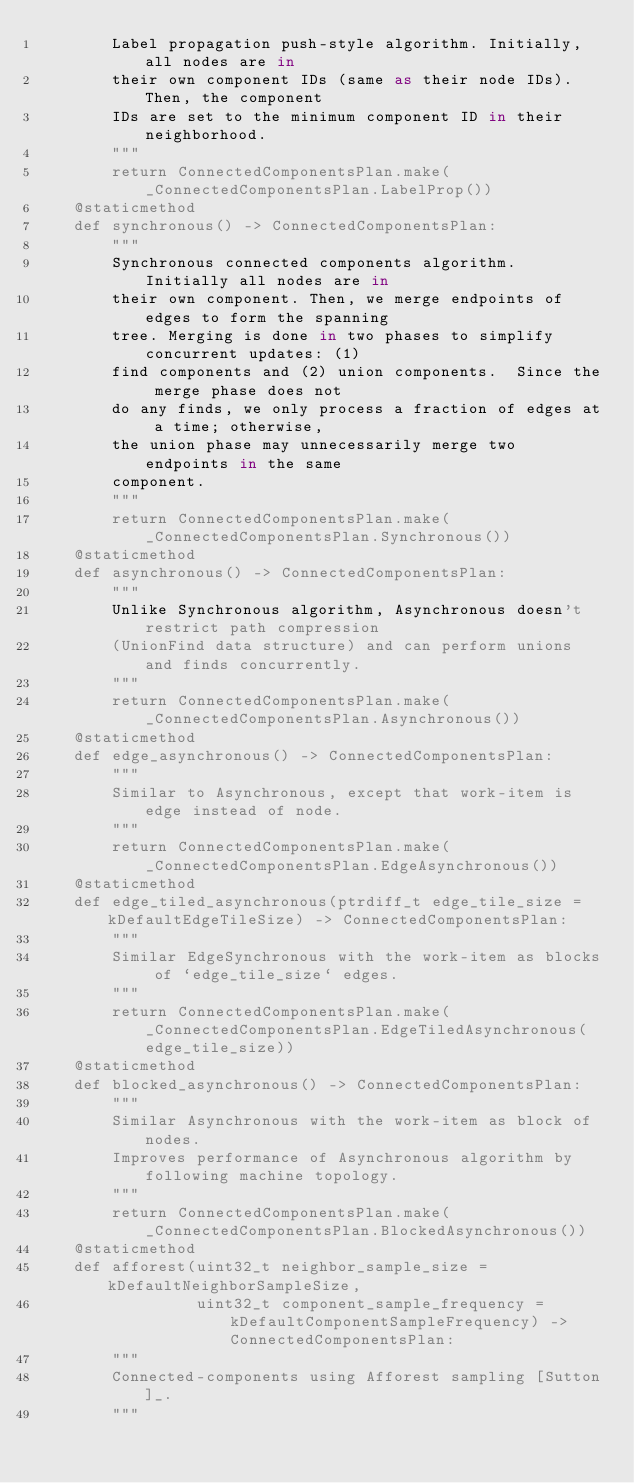<code> <loc_0><loc_0><loc_500><loc_500><_Cython_>        Label propagation push-style algorithm. Initially, all nodes are in
        their own component IDs (same as their node IDs). Then, the component
        IDs are set to the minimum component ID in their neighborhood.
        """
        return ConnectedComponentsPlan.make(_ConnectedComponentsPlan.LabelProp())
    @staticmethod
    def synchronous() -> ConnectedComponentsPlan:
        """
        Synchronous connected components algorithm.  Initially all nodes are in
        their own component. Then, we merge endpoints of edges to form the spanning
        tree. Merging is done in two phases to simplify concurrent updates: (1)
        find components and (2) union components.  Since the merge phase does not
        do any finds, we only process a fraction of edges at a time; otherwise,
        the union phase may unnecessarily merge two endpoints in the same
        component.
        """
        return ConnectedComponentsPlan.make(_ConnectedComponentsPlan.Synchronous())
    @staticmethod
    def asynchronous() -> ConnectedComponentsPlan:
        """
        Unlike Synchronous algorithm, Asynchronous doesn't restrict path compression
        (UnionFind data structure) and can perform unions and finds concurrently.
        """
        return ConnectedComponentsPlan.make(_ConnectedComponentsPlan.Asynchronous())
    @staticmethod
    def edge_asynchronous() -> ConnectedComponentsPlan:
        """
        Similar to Asynchronous, except that work-item is edge instead of node.
        """
        return ConnectedComponentsPlan.make(_ConnectedComponentsPlan.EdgeAsynchronous())
    @staticmethod
    def edge_tiled_asynchronous(ptrdiff_t edge_tile_size = kDefaultEdgeTileSize) -> ConnectedComponentsPlan:
        """
        Similar EdgeSynchronous with the work-item as blocks of `edge_tile_size` edges.
        """
        return ConnectedComponentsPlan.make(_ConnectedComponentsPlan.EdgeTiledAsynchronous(edge_tile_size))
    @staticmethod
    def blocked_asynchronous() -> ConnectedComponentsPlan:
        """
        Similar Asynchronous with the work-item as block of nodes.
        Improves performance of Asynchronous algorithm by following machine topology.
        """
        return ConnectedComponentsPlan.make(_ConnectedComponentsPlan.BlockedAsynchronous())
    @staticmethod
    def afforest(uint32_t neighbor_sample_size = kDefaultNeighborSampleSize,
                 uint32_t component_sample_frequency = kDefaultComponentSampleFrequency) -> ConnectedComponentsPlan:
        """
        Connected-components using Afforest sampling [Sutton]_.
        """</code> 